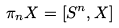<formula> <loc_0><loc_0><loc_500><loc_500>\pi _ { n } X = [ S ^ { n } , X ]</formula> 